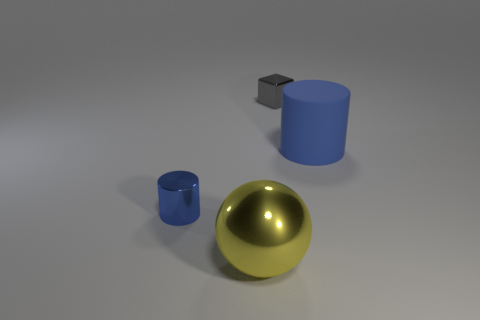The small metal object behind the cylinder on the left side of the large rubber thing is what shape? cube 